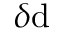<formula> <loc_0><loc_0><loc_500><loc_500>\delta d</formula> 